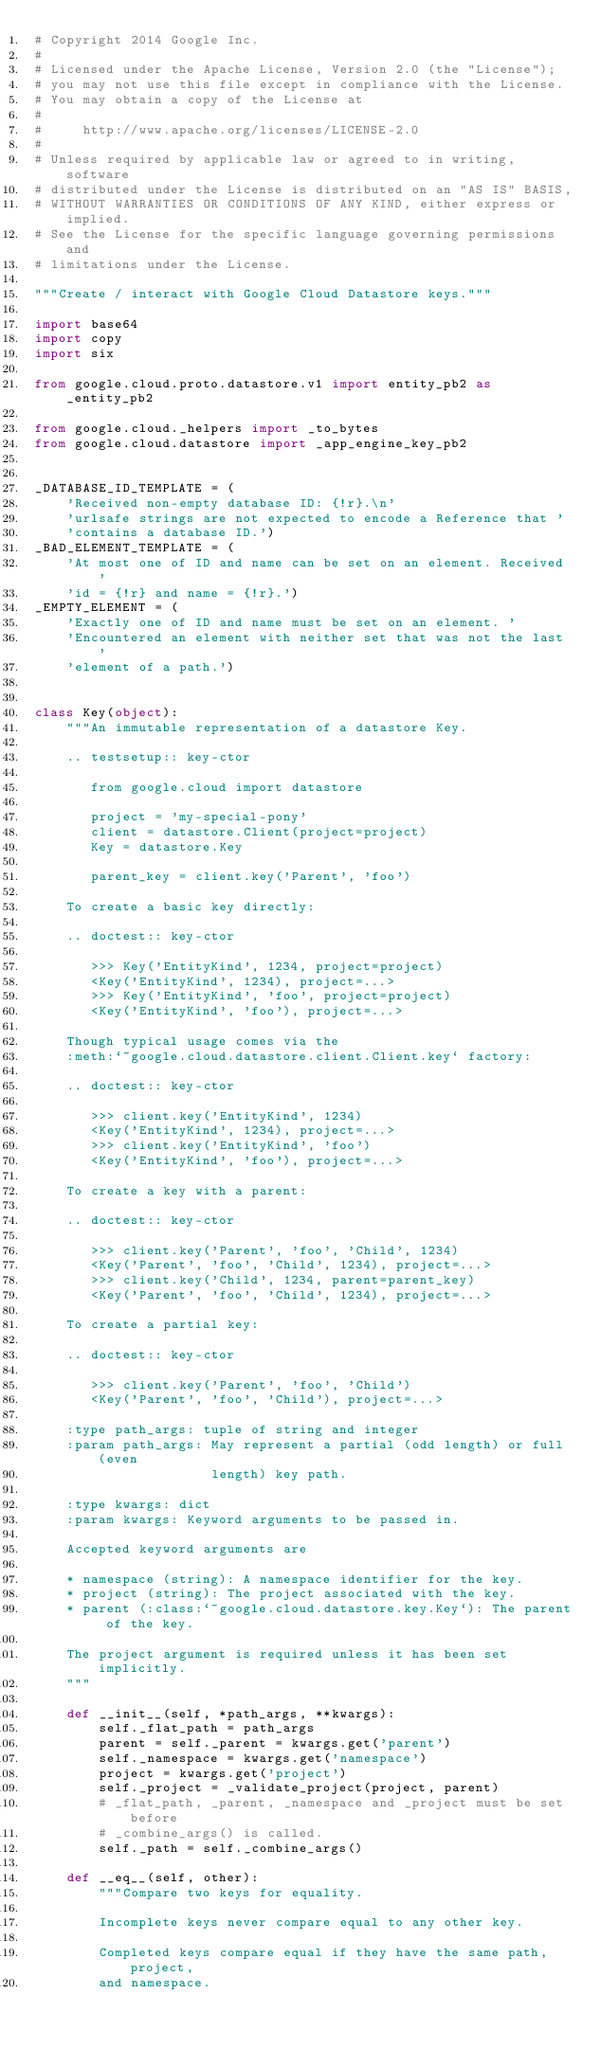Convert code to text. <code><loc_0><loc_0><loc_500><loc_500><_Python_># Copyright 2014 Google Inc.
#
# Licensed under the Apache License, Version 2.0 (the "License");
# you may not use this file except in compliance with the License.
# You may obtain a copy of the License at
#
#     http://www.apache.org/licenses/LICENSE-2.0
#
# Unless required by applicable law or agreed to in writing, software
# distributed under the License is distributed on an "AS IS" BASIS,
# WITHOUT WARRANTIES OR CONDITIONS OF ANY KIND, either express or implied.
# See the License for the specific language governing permissions and
# limitations under the License.

"""Create / interact with Google Cloud Datastore keys."""

import base64
import copy
import six

from google.cloud.proto.datastore.v1 import entity_pb2 as _entity_pb2

from google.cloud._helpers import _to_bytes
from google.cloud.datastore import _app_engine_key_pb2


_DATABASE_ID_TEMPLATE = (
    'Received non-empty database ID: {!r}.\n'
    'urlsafe strings are not expected to encode a Reference that '
    'contains a database ID.')
_BAD_ELEMENT_TEMPLATE = (
    'At most one of ID and name can be set on an element. Received '
    'id = {!r} and name = {!r}.')
_EMPTY_ELEMENT = (
    'Exactly one of ID and name must be set on an element. '
    'Encountered an element with neither set that was not the last '
    'element of a path.')


class Key(object):
    """An immutable representation of a datastore Key.

    .. testsetup:: key-ctor

       from google.cloud import datastore

       project = 'my-special-pony'
       client = datastore.Client(project=project)
       Key = datastore.Key

       parent_key = client.key('Parent', 'foo')

    To create a basic key directly:

    .. doctest:: key-ctor

       >>> Key('EntityKind', 1234, project=project)
       <Key('EntityKind', 1234), project=...>
       >>> Key('EntityKind', 'foo', project=project)
       <Key('EntityKind', 'foo'), project=...>

    Though typical usage comes via the
    :meth:`~google.cloud.datastore.client.Client.key` factory:

    .. doctest:: key-ctor

       >>> client.key('EntityKind', 1234)
       <Key('EntityKind', 1234), project=...>
       >>> client.key('EntityKind', 'foo')
       <Key('EntityKind', 'foo'), project=...>

    To create a key with a parent:

    .. doctest:: key-ctor

       >>> client.key('Parent', 'foo', 'Child', 1234)
       <Key('Parent', 'foo', 'Child', 1234), project=...>
       >>> client.key('Child', 1234, parent=parent_key)
       <Key('Parent', 'foo', 'Child', 1234), project=...>

    To create a partial key:

    .. doctest:: key-ctor

       >>> client.key('Parent', 'foo', 'Child')
       <Key('Parent', 'foo', 'Child'), project=...>

    :type path_args: tuple of string and integer
    :param path_args: May represent a partial (odd length) or full (even
                      length) key path.

    :type kwargs: dict
    :param kwargs: Keyword arguments to be passed in.

    Accepted keyword arguments are

    * namespace (string): A namespace identifier for the key.
    * project (string): The project associated with the key.
    * parent (:class:`~google.cloud.datastore.key.Key`): The parent of the key.

    The project argument is required unless it has been set implicitly.
    """

    def __init__(self, *path_args, **kwargs):
        self._flat_path = path_args
        parent = self._parent = kwargs.get('parent')
        self._namespace = kwargs.get('namespace')
        project = kwargs.get('project')
        self._project = _validate_project(project, parent)
        # _flat_path, _parent, _namespace and _project must be set before
        # _combine_args() is called.
        self._path = self._combine_args()

    def __eq__(self, other):
        """Compare two keys for equality.

        Incomplete keys never compare equal to any other key.

        Completed keys compare equal if they have the same path, project,
        and namespace.
</code> 